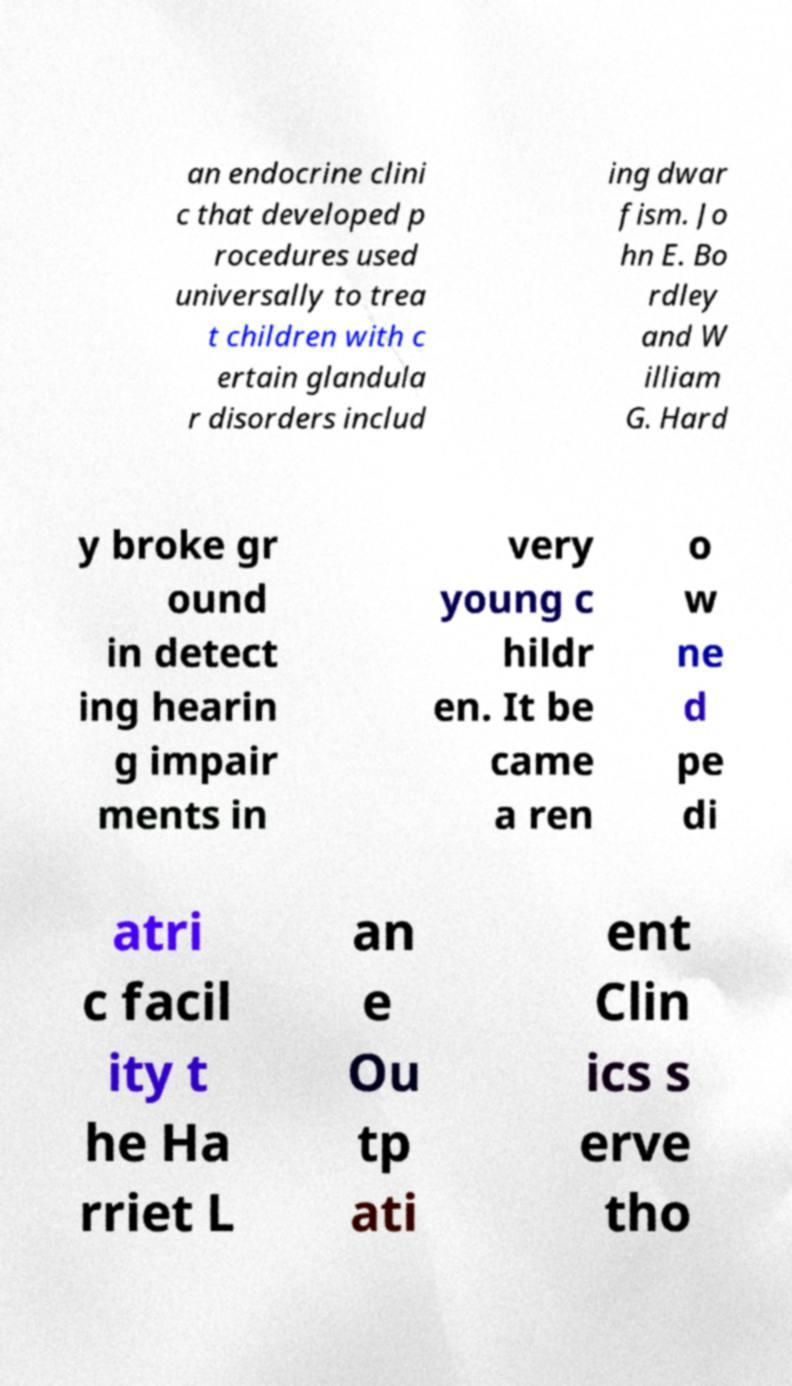For documentation purposes, I need the text within this image transcribed. Could you provide that? an endocrine clini c that developed p rocedures used universally to trea t children with c ertain glandula r disorders includ ing dwar fism. Jo hn E. Bo rdley and W illiam G. Hard y broke gr ound in detect ing hearin g impair ments in very young c hildr en. It be came a ren o w ne d pe di atri c facil ity t he Ha rriet L an e Ou tp ati ent Clin ics s erve tho 